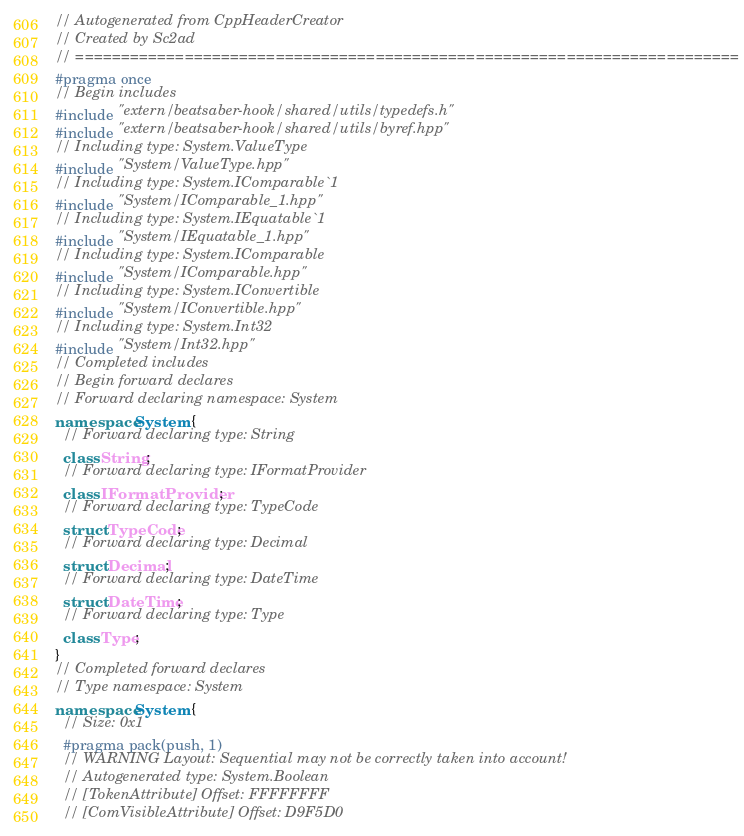<code> <loc_0><loc_0><loc_500><loc_500><_C++_>// Autogenerated from CppHeaderCreator
// Created by Sc2ad
// =========================================================================
#pragma once
// Begin includes
#include "extern/beatsaber-hook/shared/utils/typedefs.h"
#include "extern/beatsaber-hook/shared/utils/byref.hpp"
// Including type: System.ValueType
#include "System/ValueType.hpp"
// Including type: System.IComparable`1
#include "System/IComparable_1.hpp"
// Including type: System.IEquatable`1
#include "System/IEquatable_1.hpp"
// Including type: System.IComparable
#include "System/IComparable.hpp"
// Including type: System.IConvertible
#include "System/IConvertible.hpp"
// Including type: System.Int32
#include "System/Int32.hpp"
// Completed includes
// Begin forward declares
// Forward declaring namespace: System
namespace System {
  // Forward declaring type: String
  class String;
  // Forward declaring type: IFormatProvider
  class IFormatProvider;
  // Forward declaring type: TypeCode
  struct TypeCode;
  // Forward declaring type: Decimal
  struct Decimal;
  // Forward declaring type: DateTime
  struct DateTime;
  // Forward declaring type: Type
  class Type;
}
// Completed forward declares
// Type namespace: System
namespace System {
  // Size: 0x1
  #pragma pack(push, 1)
  // WARNING Layout: Sequential may not be correctly taken into account!
  // Autogenerated type: System.Boolean
  // [TokenAttribute] Offset: FFFFFFFF
  // [ComVisibleAttribute] Offset: D9F5D0</code> 